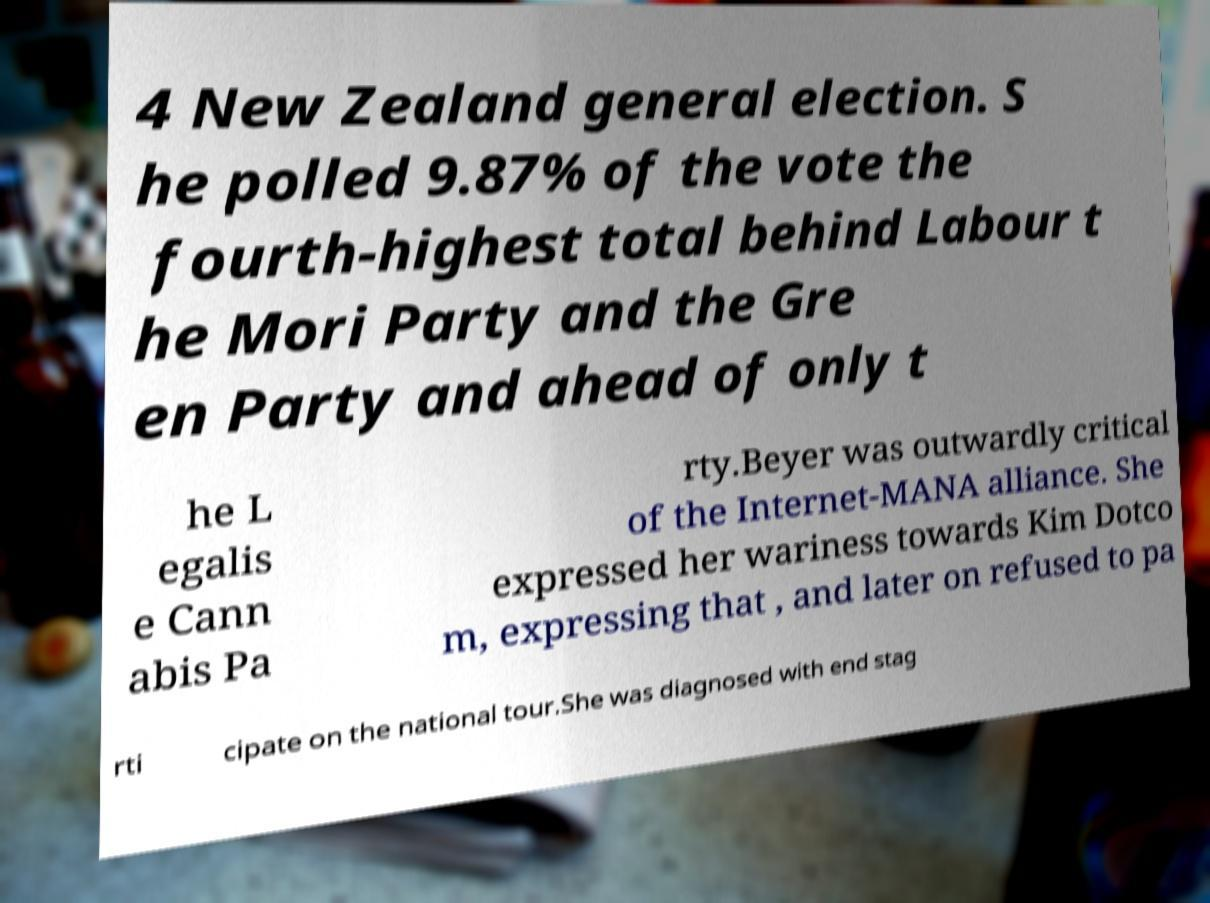Could you extract and type out the text from this image? 4 New Zealand general election. S he polled 9.87% of the vote the fourth-highest total behind Labour t he Mori Party and the Gre en Party and ahead of only t he L egalis e Cann abis Pa rty.Beyer was outwardly critical of the Internet-MANA alliance. She expressed her wariness towards Kim Dotco m, expressing that , and later on refused to pa rti cipate on the national tour.She was diagnosed with end stag 